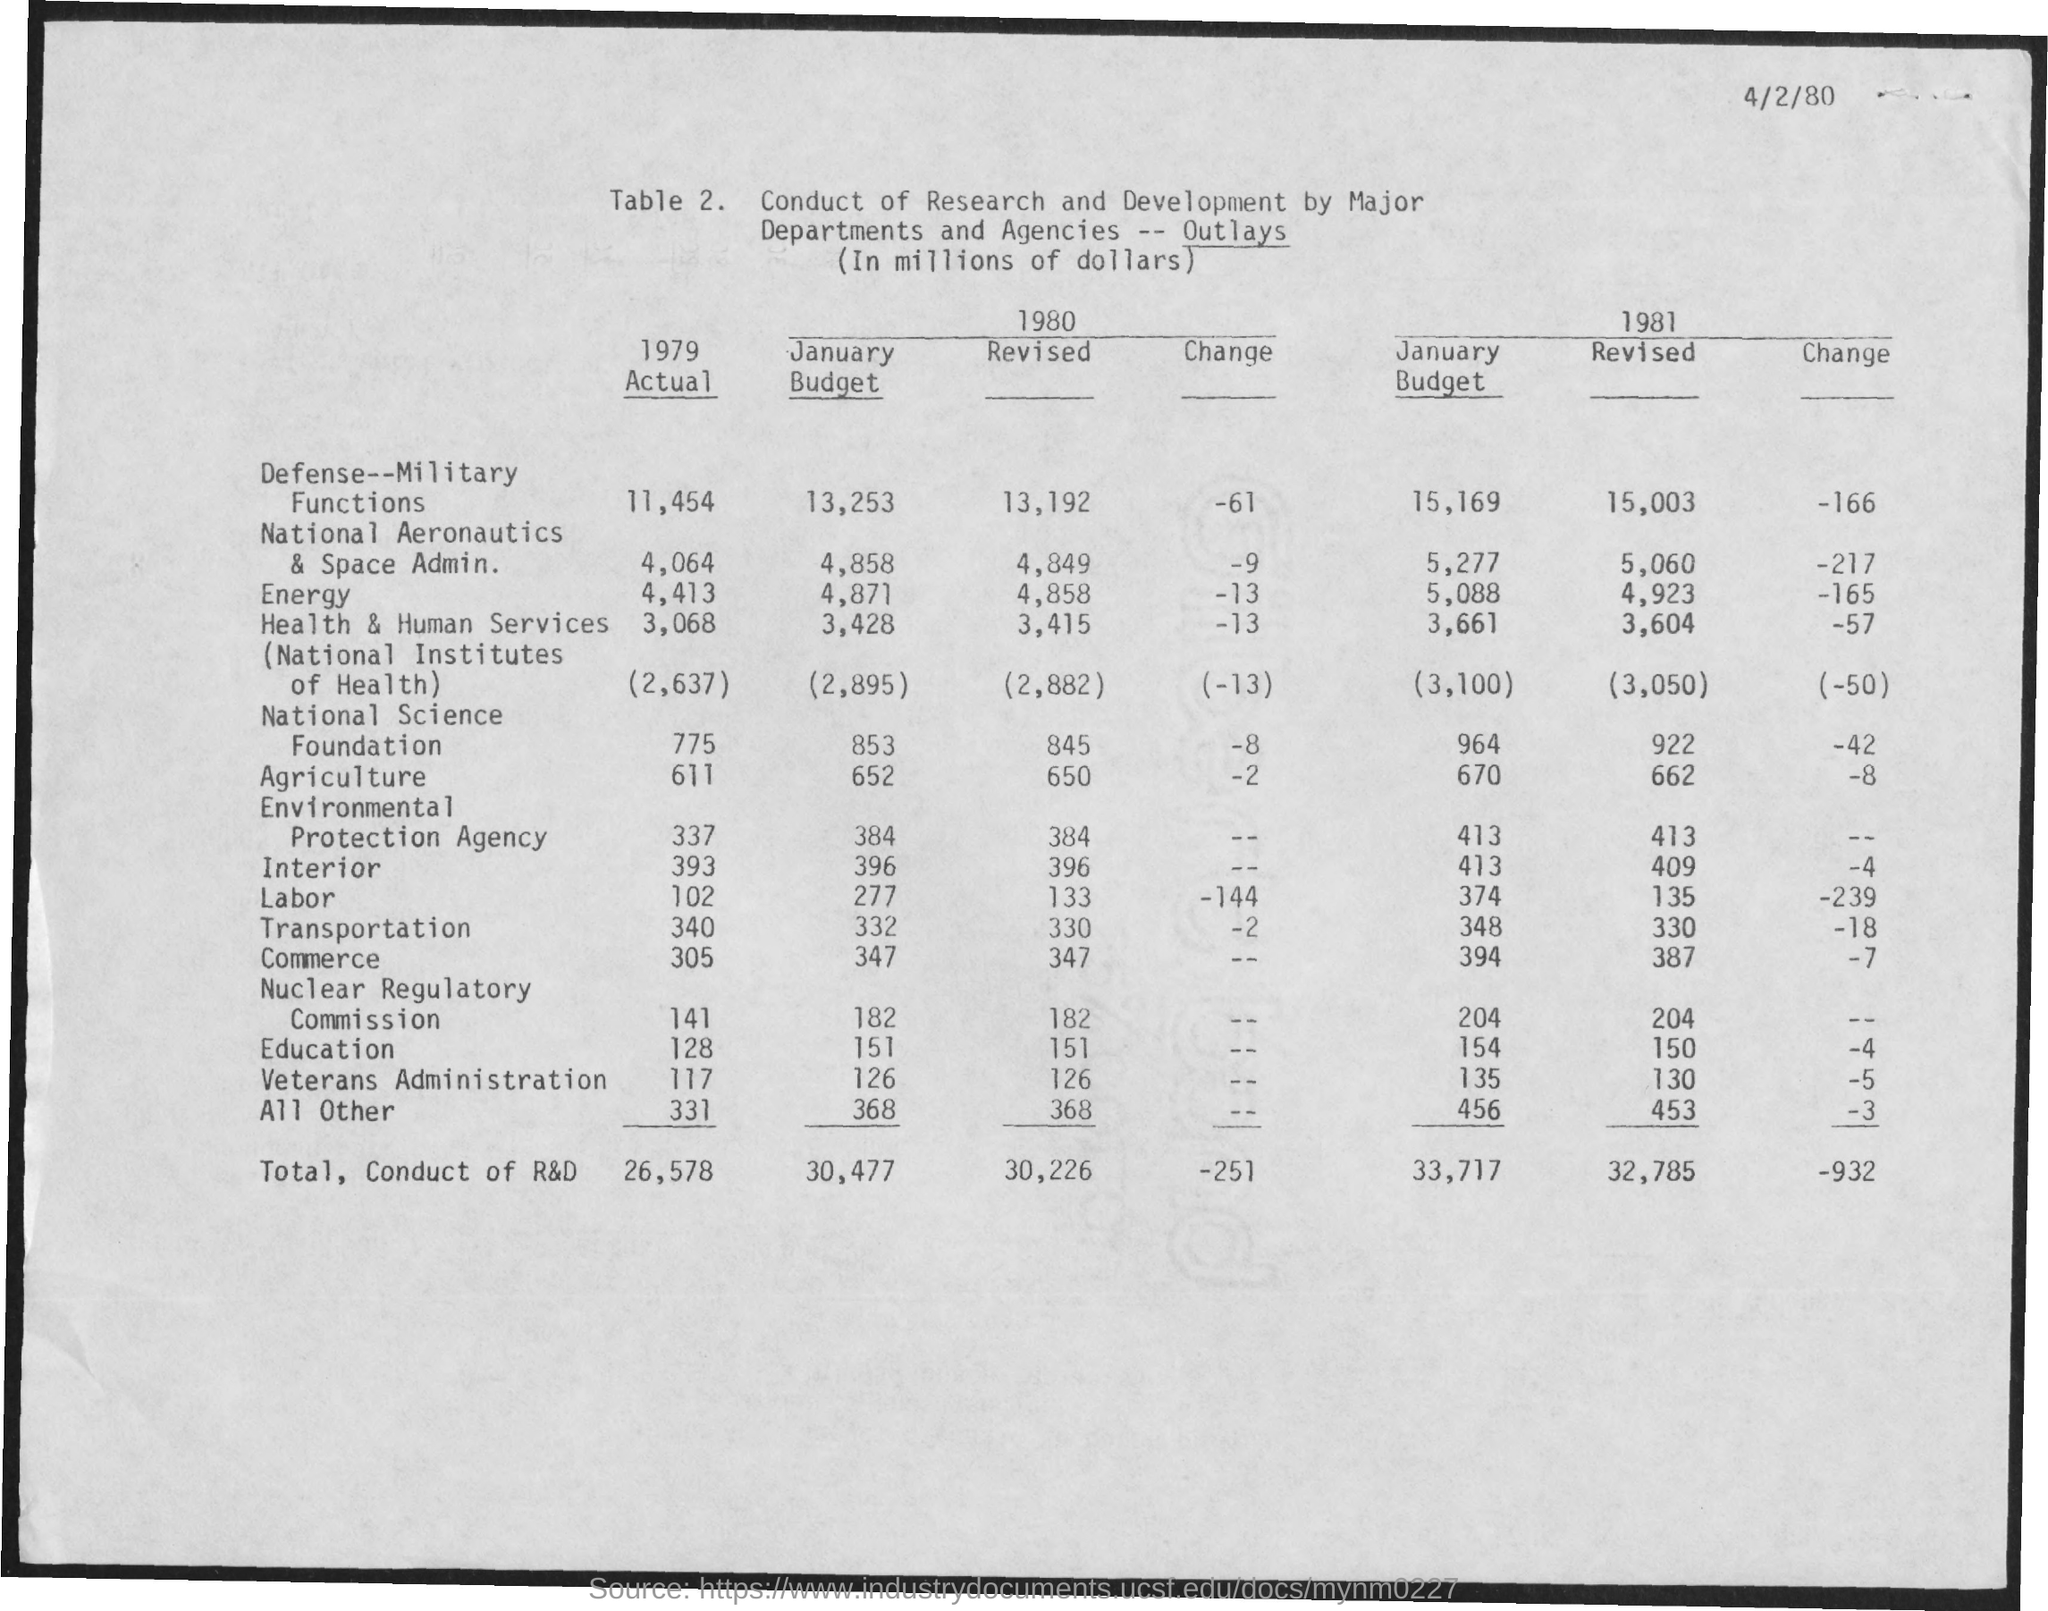Give some essential details in this illustration. The date mentioned in the document is 4/2/80. 